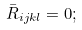<formula> <loc_0><loc_0><loc_500><loc_500>\bar { R } _ { i j k l } = 0 ;</formula> 